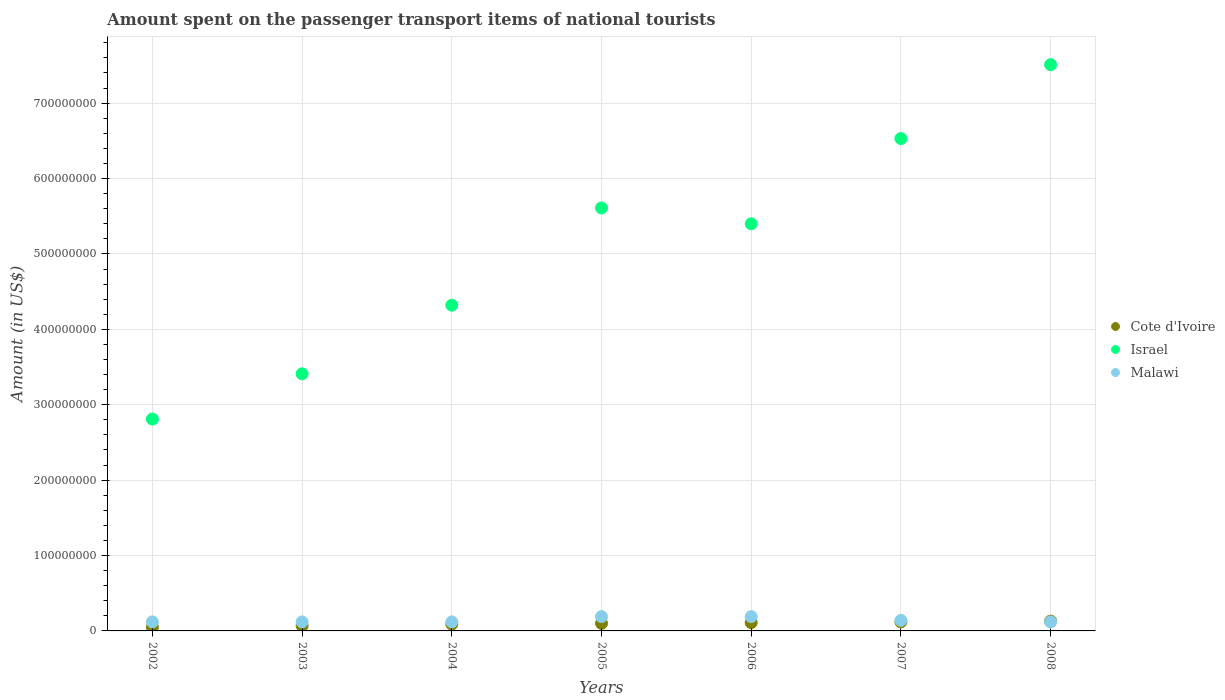What is the amount spent on the passenger transport items of national tourists in Malawi in 2005?
Provide a succinct answer. 1.90e+07. Across all years, what is the maximum amount spent on the passenger transport items of national tourists in Malawi?
Your answer should be very brief. 1.90e+07. Across all years, what is the minimum amount spent on the passenger transport items of national tourists in Israel?
Make the answer very short. 2.81e+08. In which year was the amount spent on the passenger transport items of national tourists in Cote d'Ivoire maximum?
Offer a terse response. 2008. What is the total amount spent on the passenger transport items of national tourists in Israel in the graph?
Your answer should be compact. 3.56e+09. What is the difference between the amount spent on the passenger transport items of national tourists in Cote d'Ivoire in 2003 and that in 2007?
Provide a short and direct response. -5.00e+06. What is the average amount spent on the passenger transport items of national tourists in Cote d'Ivoire per year?
Provide a succinct answer. 9.57e+06. In the year 2008, what is the difference between the amount spent on the passenger transport items of national tourists in Malawi and amount spent on the passenger transport items of national tourists in Israel?
Give a very brief answer. -7.39e+08. What is the ratio of the amount spent on the passenger transport items of national tourists in Israel in 2004 to that in 2008?
Your answer should be compact. 0.58. Is the difference between the amount spent on the passenger transport items of national tourists in Malawi in 2003 and 2006 greater than the difference between the amount spent on the passenger transport items of national tourists in Israel in 2003 and 2006?
Keep it short and to the point. Yes. What is the difference between the highest and the second highest amount spent on the passenger transport items of national tourists in Israel?
Provide a succinct answer. 9.80e+07. What is the difference between the highest and the lowest amount spent on the passenger transport items of national tourists in Malawi?
Your answer should be very brief. 7.00e+06. How many years are there in the graph?
Keep it short and to the point. 7. Does the graph contain any zero values?
Offer a very short reply. No. Does the graph contain grids?
Offer a terse response. Yes. Where does the legend appear in the graph?
Provide a succinct answer. Center right. What is the title of the graph?
Give a very brief answer. Amount spent on the passenger transport items of national tourists. What is the label or title of the Y-axis?
Provide a succinct answer. Amount (in US$). What is the Amount (in US$) in Cote d'Ivoire in 2002?
Offer a terse response. 5.00e+06. What is the Amount (in US$) of Israel in 2002?
Your answer should be compact. 2.81e+08. What is the Amount (in US$) of Malawi in 2002?
Your answer should be very brief. 1.20e+07. What is the Amount (in US$) in Israel in 2003?
Make the answer very short. 3.41e+08. What is the Amount (in US$) of Malawi in 2003?
Offer a terse response. 1.20e+07. What is the Amount (in US$) in Cote d'Ivoire in 2004?
Your answer should be very brief. 9.00e+06. What is the Amount (in US$) in Israel in 2004?
Offer a very short reply. 4.32e+08. What is the Amount (in US$) in Malawi in 2004?
Make the answer very short. 1.20e+07. What is the Amount (in US$) in Israel in 2005?
Provide a succinct answer. 5.61e+08. What is the Amount (in US$) of Malawi in 2005?
Provide a succinct answer. 1.90e+07. What is the Amount (in US$) in Cote d'Ivoire in 2006?
Your answer should be very brief. 1.10e+07. What is the Amount (in US$) in Israel in 2006?
Make the answer very short. 5.40e+08. What is the Amount (in US$) in Malawi in 2006?
Your answer should be compact. 1.90e+07. What is the Amount (in US$) in Cote d'Ivoire in 2007?
Your answer should be very brief. 1.20e+07. What is the Amount (in US$) in Israel in 2007?
Keep it short and to the point. 6.53e+08. What is the Amount (in US$) in Malawi in 2007?
Provide a short and direct response. 1.40e+07. What is the Amount (in US$) in Cote d'Ivoire in 2008?
Keep it short and to the point. 1.30e+07. What is the Amount (in US$) of Israel in 2008?
Your answer should be very brief. 7.51e+08. What is the Amount (in US$) of Malawi in 2008?
Provide a short and direct response. 1.20e+07. Across all years, what is the maximum Amount (in US$) of Cote d'Ivoire?
Provide a short and direct response. 1.30e+07. Across all years, what is the maximum Amount (in US$) in Israel?
Give a very brief answer. 7.51e+08. Across all years, what is the maximum Amount (in US$) in Malawi?
Your answer should be very brief. 1.90e+07. Across all years, what is the minimum Amount (in US$) of Israel?
Offer a very short reply. 2.81e+08. What is the total Amount (in US$) in Cote d'Ivoire in the graph?
Keep it short and to the point. 6.70e+07. What is the total Amount (in US$) of Israel in the graph?
Your answer should be very brief. 3.56e+09. What is the total Amount (in US$) of Malawi in the graph?
Your answer should be compact. 1.00e+08. What is the difference between the Amount (in US$) of Israel in 2002 and that in 2003?
Your answer should be very brief. -6.00e+07. What is the difference between the Amount (in US$) in Israel in 2002 and that in 2004?
Offer a terse response. -1.51e+08. What is the difference between the Amount (in US$) in Cote d'Ivoire in 2002 and that in 2005?
Offer a very short reply. -5.00e+06. What is the difference between the Amount (in US$) in Israel in 2002 and that in 2005?
Provide a short and direct response. -2.80e+08. What is the difference between the Amount (in US$) in Malawi in 2002 and that in 2005?
Give a very brief answer. -7.00e+06. What is the difference between the Amount (in US$) in Cote d'Ivoire in 2002 and that in 2006?
Offer a terse response. -6.00e+06. What is the difference between the Amount (in US$) of Israel in 2002 and that in 2006?
Your answer should be compact. -2.59e+08. What is the difference between the Amount (in US$) in Malawi in 2002 and that in 2006?
Give a very brief answer. -7.00e+06. What is the difference between the Amount (in US$) in Cote d'Ivoire in 2002 and that in 2007?
Your answer should be compact. -7.00e+06. What is the difference between the Amount (in US$) of Israel in 2002 and that in 2007?
Make the answer very short. -3.72e+08. What is the difference between the Amount (in US$) in Malawi in 2002 and that in 2007?
Your response must be concise. -2.00e+06. What is the difference between the Amount (in US$) of Cote d'Ivoire in 2002 and that in 2008?
Your answer should be compact. -8.00e+06. What is the difference between the Amount (in US$) in Israel in 2002 and that in 2008?
Ensure brevity in your answer.  -4.70e+08. What is the difference between the Amount (in US$) in Israel in 2003 and that in 2004?
Offer a terse response. -9.10e+07. What is the difference between the Amount (in US$) in Cote d'Ivoire in 2003 and that in 2005?
Ensure brevity in your answer.  -3.00e+06. What is the difference between the Amount (in US$) in Israel in 2003 and that in 2005?
Your response must be concise. -2.20e+08. What is the difference between the Amount (in US$) of Malawi in 2003 and that in 2005?
Offer a terse response. -7.00e+06. What is the difference between the Amount (in US$) of Israel in 2003 and that in 2006?
Offer a terse response. -1.99e+08. What is the difference between the Amount (in US$) of Malawi in 2003 and that in 2006?
Provide a short and direct response. -7.00e+06. What is the difference between the Amount (in US$) of Cote d'Ivoire in 2003 and that in 2007?
Provide a short and direct response. -5.00e+06. What is the difference between the Amount (in US$) of Israel in 2003 and that in 2007?
Ensure brevity in your answer.  -3.12e+08. What is the difference between the Amount (in US$) in Malawi in 2003 and that in 2007?
Your answer should be compact. -2.00e+06. What is the difference between the Amount (in US$) in Cote d'Ivoire in 2003 and that in 2008?
Your answer should be very brief. -6.00e+06. What is the difference between the Amount (in US$) in Israel in 2003 and that in 2008?
Your response must be concise. -4.10e+08. What is the difference between the Amount (in US$) of Malawi in 2003 and that in 2008?
Offer a very short reply. 0. What is the difference between the Amount (in US$) of Cote d'Ivoire in 2004 and that in 2005?
Give a very brief answer. -1.00e+06. What is the difference between the Amount (in US$) of Israel in 2004 and that in 2005?
Keep it short and to the point. -1.29e+08. What is the difference between the Amount (in US$) in Malawi in 2004 and that in 2005?
Your answer should be very brief. -7.00e+06. What is the difference between the Amount (in US$) of Israel in 2004 and that in 2006?
Offer a terse response. -1.08e+08. What is the difference between the Amount (in US$) in Malawi in 2004 and that in 2006?
Your answer should be compact. -7.00e+06. What is the difference between the Amount (in US$) of Cote d'Ivoire in 2004 and that in 2007?
Give a very brief answer. -3.00e+06. What is the difference between the Amount (in US$) of Israel in 2004 and that in 2007?
Your answer should be compact. -2.21e+08. What is the difference between the Amount (in US$) in Malawi in 2004 and that in 2007?
Offer a very short reply. -2.00e+06. What is the difference between the Amount (in US$) in Israel in 2004 and that in 2008?
Your answer should be very brief. -3.19e+08. What is the difference between the Amount (in US$) of Malawi in 2004 and that in 2008?
Your answer should be very brief. 0. What is the difference between the Amount (in US$) of Israel in 2005 and that in 2006?
Provide a succinct answer. 2.10e+07. What is the difference between the Amount (in US$) of Malawi in 2005 and that in 2006?
Your answer should be compact. 0. What is the difference between the Amount (in US$) in Israel in 2005 and that in 2007?
Your answer should be compact. -9.20e+07. What is the difference between the Amount (in US$) in Malawi in 2005 and that in 2007?
Your answer should be very brief. 5.00e+06. What is the difference between the Amount (in US$) of Israel in 2005 and that in 2008?
Your answer should be compact. -1.90e+08. What is the difference between the Amount (in US$) in Israel in 2006 and that in 2007?
Ensure brevity in your answer.  -1.13e+08. What is the difference between the Amount (in US$) of Malawi in 2006 and that in 2007?
Make the answer very short. 5.00e+06. What is the difference between the Amount (in US$) of Cote d'Ivoire in 2006 and that in 2008?
Offer a terse response. -2.00e+06. What is the difference between the Amount (in US$) in Israel in 2006 and that in 2008?
Provide a succinct answer. -2.11e+08. What is the difference between the Amount (in US$) in Cote d'Ivoire in 2007 and that in 2008?
Keep it short and to the point. -1.00e+06. What is the difference between the Amount (in US$) in Israel in 2007 and that in 2008?
Give a very brief answer. -9.80e+07. What is the difference between the Amount (in US$) in Cote d'Ivoire in 2002 and the Amount (in US$) in Israel in 2003?
Your response must be concise. -3.36e+08. What is the difference between the Amount (in US$) of Cote d'Ivoire in 2002 and the Amount (in US$) of Malawi in 2003?
Provide a succinct answer. -7.00e+06. What is the difference between the Amount (in US$) in Israel in 2002 and the Amount (in US$) in Malawi in 2003?
Ensure brevity in your answer.  2.69e+08. What is the difference between the Amount (in US$) in Cote d'Ivoire in 2002 and the Amount (in US$) in Israel in 2004?
Offer a terse response. -4.27e+08. What is the difference between the Amount (in US$) in Cote d'Ivoire in 2002 and the Amount (in US$) in Malawi in 2004?
Offer a very short reply. -7.00e+06. What is the difference between the Amount (in US$) of Israel in 2002 and the Amount (in US$) of Malawi in 2004?
Provide a succinct answer. 2.69e+08. What is the difference between the Amount (in US$) in Cote d'Ivoire in 2002 and the Amount (in US$) in Israel in 2005?
Offer a very short reply. -5.56e+08. What is the difference between the Amount (in US$) of Cote d'Ivoire in 2002 and the Amount (in US$) of Malawi in 2005?
Your answer should be compact. -1.40e+07. What is the difference between the Amount (in US$) of Israel in 2002 and the Amount (in US$) of Malawi in 2005?
Offer a very short reply. 2.62e+08. What is the difference between the Amount (in US$) in Cote d'Ivoire in 2002 and the Amount (in US$) in Israel in 2006?
Provide a short and direct response. -5.35e+08. What is the difference between the Amount (in US$) in Cote d'Ivoire in 2002 and the Amount (in US$) in Malawi in 2006?
Provide a succinct answer. -1.40e+07. What is the difference between the Amount (in US$) of Israel in 2002 and the Amount (in US$) of Malawi in 2006?
Your answer should be very brief. 2.62e+08. What is the difference between the Amount (in US$) of Cote d'Ivoire in 2002 and the Amount (in US$) of Israel in 2007?
Give a very brief answer. -6.48e+08. What is the difference between the Amount (in US$) in Cote d'Ivoire in 2002 and the Amount (in US$) in Malawi in 2007?
Your answer should be very brief. -9.00e+06. What is the difference between the Amount (in US$) in Israel in 2002 and the Amount (in US$) in Malawi in 2007?
Your response must be concise. 2.67e+08. What is the difference between the Amount (in US$) in Cote d'Ivoire in 2002 and the Amount (in US$) in Israel in 2008?
Your answer should be very brief. -7.46e+08. What is the difference between the Amount (in US$) of Cote d'Ivoire in 2002 and the Amount (in US$) of Malawi in 2008?
Ensure brevity in your answer.  -7.00e+06. What is the difference between the Amount (in US$) in Israel in 2002 and the Amount (in US$) in Malawi in 2008?
Offer a terse response. 2.69e+08. What is the difference between the Amount (in US$) of Cote d'Ivoire in 2003 and the Amount (in US$) of Israel in 2004?
Make the answer very short. -4.25e+08. What is the difference between the Amount (in US$) in Cote d'Ivoire in 2003 and the Amount (in US$) in Malawi in 2004?
Provide a succinct answer. -5.00e+06. What is the difference between the Amount (in US$) of Israel in 2003 and the Amount (in US$) of Malawi in 2004?
Keep it short and to the point. 3.29e+08. What is the difference between the Amount (in US$) in Cote d'Ivoire in 2003 and the Amount (in US$) in Israel in 2005?
Give a very brief answer. -5.54e+08. What is the difference between the Amount (in US$) of Cote d'Ivoire in 2003 and the Amount (in US$) of Malawi in 2005?
Keep it short and to the point. -1.20e+07. What is the difference between the Amount (in US$) of Israel in 2003 and the Amount (in US$) of Malawi in 2005?
Give a very brief answer. 3.22e+08. What is the difference between the Amount (in US$) of Cote d'Ivoire in 2003 and the Amount (in US$) of Israel in 2006?
Keep it short and to the point. -5.33e+08. What is the difference between the Amount (in US$) of Cote d'Ivoire in 2003 and the Amount (in US$) of Malawi in 2006?
Your response must be concise. -1.20e+07. What is the difference between the Amount (in US$) of Israel in 2003 and the Amount (in US$) of Malawi in 2006?
Keep it short and to the point. 3.22e+08. What is the difference between the Amount (in US$) in Cote d'Ivoire in 2003 and the Amount (in US$) in Israel in 2007?
Give a very brief answer. -6.46e+08. What is the difference between the Amount (in US$) of Cote d'Ivoire in 2003 and the Amount (in US$) of Malawi in 2007?
Offer a very short reply. -7.00e+06. What is the difference between the Amount (in US$) of Israel in 2003 and the Amount (in US$) of Malawi in 2007?
Your answer should be very brief. 3.27e+08. What is the difference between the Amount (in US$) in Cote d'Ivoire in 2003 and the Amount (in US$) in Israel in 2008?
Your answer should be compact. -7.44e+08. What is the difference between the Amount (in US$) in Cote d'Ivoire in 2003 and the Amount (in US$) in Malawi in 2008?
Provide a succinct answer. -5.00e+06. What is the difference between the Amount (in US$) in Israel in 2003 and the Amount (in US$) in Malawi in 2008?
Your answer should be very brief. 3.29e+08. What is the difference between the Amount (in US$) in Cote d'Ivoire in 2004 and the Amount (in US$) in Israel in 2005?
Your answer should be compact. -5.52e+08. What is the difference between the Amount (in US$) in Cote d'Ivoire in 2004 and the Amount (in US$) in Malawi in 2005?
Your answer should be compact. -1.00e+07. What is the difference between the Amount (in US$) of Israel in 2004 and the Amount (in US$) of Malawi in 2005?
Offer a terse response. 4.13e+08. What is the difference between the Amount (in US$) of Cote d'Ivoire in 2004 and the Amount (in US$) of Israel in 2006?
Offer a very short reply. -5.31e+08. What is the difference between the Amount (in US$) of Cote d'Ivoire in 2004 and the Amount (in US$) of Malawi in 2006?
Your answer should be very brief. -1.00e+07. What is the difference between the Amount (in US$) in Israel in 2004 and the Amount (in US$) in Malawi in 2006?
Your response must be concise. 4.13e+08. What is the difference between the Amount (in US$) in Cote d'Ivoire in 2004 and the Amount (in US$) in Israel in 2007?
Provide a short and direct response. -6.44e+08. What is the difference between the Amount (in US$) of Cote d'Ivoire in 2004 and the Amount (in US$) of Malawi in 2007?
Ensure brevity in your answer.  -5.00e+06. What is the difference between the Amount (in US$) in Israel in 2004 and the Amount (in US$) in Malawi in 2007?
Ensure brevity in your answer.  4.18e+08. What is the difference between the Amount (in US$) in Cote d'Ivoire in 2004 and the Amount (in US$) in Israel in 2008?
Make the answer very short. -7.42e+08. What is the difference between the Amount (in US$) of Israel in 2004 and the Amount (in US$) of Malawi in 2008?
Give a very brief answer. 4.20e+08. What is the difference between the Amount (in US$) of Cote d'Ivoire in 2005 and the Amount (in US$) of Israel in 2006?
Your answer should be compact. -5.30e+08. What is the difference between the Amount (in US$) in Cote d'Ivoire in 2005 and the Amount (in US$) in Malawi in 2006?
Ensure brevity in your answer.  -9.00e+06. What is the difference between the Amount (in US$) of Israel in 2005 and the Amount (in US$) of Malawi in 2006?
Keep it short and to the point. 5.42e+08. What is the difference between the Amount (in US$) in Cote d'Ivoire in 2005 and the Amount (in US$) in Israel in 2007?
Keep it short and to the point. -6.43e+08. What is the difference between the Amount (in US$) in Cote d'Ivoire in 2005 and the Amount (in US$) in Malawi in 2007?
Offer a terse response. -4.00e+06. What is the difference between the Amount (in US$) of Israel in 2005 and the Amount (in US$) of Malawi in 2007?
Your response must be concise. 5.47e+08. What is the difference between the Amount (in US$) in Cote d'Ivoire in 2005 and the Amount (in US$) in Israel in 2008?
Give a very brief answer. -7.41e+08. What is the difference between the Amount (in US$) in Cote d'Ivoire in 2005 and the Amount (in US$) in Malawi in 2008?
Provide a succinct answer. -2.00e+06. What is the difference between the Amount (in US$) in Israel in 2005 and the Amount (in US$) in Malawi in 2008?
Keep it short and to the point. 5.49e+08. What is the difference between the Amount (in US$) in Cote d'Ivoire in 2006 and the Amount (in US$) in Israel in 2007?
Keep it short and to the point. -6.42e+08. What is the difference between the Amount (in US$) of Israel in 2006 and the Amount (in US$) of Malawi in 2007?
Your answer should be very brief. 5.26e+08. What is the difference between the Amount (in US$) in Cote d'Ivoire in 2006 and the Amount (in US$) in Israel in 2008?
Make the answer very short. -7.40e+08. What is the difference between the Amount (in US$) in Cote d'Ivoire in 2006 and the Amount (in US$) in Malawi in 2008?
Your answer should be compact. -1.00e+06. What is the difference between the Amount (in US$) in Israel in 2006 and the Amount (in US$) in Malawi in 2008?
Your response must be concise. 5.28e+08. What is the difference between the Amount (in US$) of Cote d'Ivoire in 2007 and the Amount (in US$) of Israel in 2008?
Your answer should be very brief. -7.39e+08. What is the difference between the Amount (in US$) in Cote d'Ivoire in 2007 and the Amount (in US$) in Malawi in 2008?
Give a very brief answer. 0. What is the difference between the Amount (in US$) of Israel in 2007 and the Amount (in US$) of Malawi in 2008?
Give a very brief answer. 6.41e+08. What is the average Amount (in US$) in Cote d'Ivoire per year?
Give a very brief answer. 9.57e+06. What is the average Amount (in US$) in Israel per year?
Ensure brevity in your answer.  5.08e+08. What is the average Amount (in US$) in Malawi per year?
Offer a very short reply. 1.43e+07. In the year 2002, what is the difference between the Amount (in US$) in Cote d'Ivoire and Amount (in US$) in Israel?
Your response must be concise. -2.76e+08. In the year 2002, what is the difference between the Amount (in US$) in Cote d'Ivoire and Amount (in US$) in Malawi?
Your answer should be compact. -7.00e+06. In the year 2002, what is the difference between the Amount (in US$) of Israel and Amount (in US$) of Malawi?
Provide a succinct answer. 2.69e+08. In the year 2003, what is the difference between the Amount (in US$) in Cote d'Ivoire and Amount (in US$) in Israel?
Give a very brief answer. -3.34e+08. In the year 2003, what is the difference between the Amount (in US$) of Cote d'Ivoire and Amount (in US$) of Malawi?
Offer a terse response. -5.00e+06. In the year 2003, what is the difference between the Amount (in US$) in Israel and Amount (in US$) in Malawi?
Your response must be concise. 3.29e+08. In the year 2004, what is the difference between the Amount (in US$) in Cote d'Ivoire and Amount (in US$) in Israel?
Provide a succinct answer. -4.23e+08. In the year 2004, what is the difference between the Amount (in US$) in Cote d'Ivoire and Amount (in US$) in Malawi?
Provide a short and direct response. -3.00e+06. In the year 2004, what is the difference between the Amount (in US$) in Israel and Amount (in US$) in Malawi?
Your response must be concise. 4.20e+08. In the year 2005, what is the difference between the Amount (in US$) of Cote d'Ivoire and Amount (in US$) of Israel?
Make the answer very short. -5.51e+08. In the year 2005, what is the difference between the Amount (in US$) in Cote d'Ivoire and Amount (in US$) in Malawi?
Provide a short and direct response. -9.00e+06. In the year 2005, what is the difference between the Amount (in US$) in Israel and Amount (in US$) in Malawi?
Make the answer very short. 5.42e+08. In the year 2006, what is the difference between the Amount (in US$) in Cote d'Ivoire and Amount (in US$) in Israel?
Ensure brevity in your answer.  -5.29e+08. In the year 2006, what is the difference between the Amount (in US$) in Cote d'Ivoire and Amount (in US$) in Malawi?
Keep it short and to the point. -8.00e+06. In the year 2006, what is the difference between the Amount (in US$) of Israel and Amount (in US$) of Malawi?
Your response must be concise. 5.21e+08. In the year 2007, what is the difference between the Amount (in US$) of Cote d'Ivoire and Amount (in US$) of Israel?
Your answer should be compact. -6.41e+08. In the year 2007, what is the difference between the Amount (in US$) of Cote d'Ivoire and Amount (in US$) of Malawi?
Keep it short and to the point. -2.00e+06. In the year 2007, what is the difference between the Amount (in US$) in Israel and Amount (in US$) in Malawi?
Offer a terse response. 6.39e+08. In the year 2008, what is the difference between the Amount (in US$) in Cote d'Ivoire and Amount (in US$) in Israel?
Provide a short and direct response. -7.38e+08. In the year 2008, what is the difference between the Amount (in US$) of Israel and Amount (in US$) of Malawi?
Your answer should be very brief. 7.39e+08. What is the ratio of the Amount (in US$) of Cote d'Ivoire in 2002 to that in 2003?
Your response must be concise. 0.71. What is the ratio of the Amount (in US$) in Israel in 2002 to that in 2003?
Your answer should be very brief. 0.82. What is the ratio of the Amount (in US$) of Malawi in 2002 to that in 2003?
Give a very brief answer. 1. What is the ratio of the Amount (in US$) in Cote d'Ivoire in 2002 to that in 2004?
Your answer should be very brief. 0.56. What is the ratio of the Amount (in US$) of Israel in 2002 to that in 2004?
Offer a very short reply. 0.65. What is the ratio of the Amount (in US$) in Malawi in 2002 to that in 2004?
Provide a succinct answer. 1. What is the ratio of the Amount (in US$) of Cote d'Ivoire in 2002 to that in 2005?
Your answer should be very brief. 0.5. What is the ratio of the Amount (in US$) in Israel in 2002 to that in 2005?
Your answer should be compact. 0.5. What is the ratio of the Amount (in US$) of Malawi in 2002 to that in 2005?
Your response must be concise. 0.63. What is the ratio of the Amount (in US$) in Cote d'Ivoire in 2002 to that in 2006?
Provide a short and direct response. 0.45. What is the ratio of the Amount (in US$) of Israel in 2002 to that in 2006?
Ensure brevity in your answer.  0.52. What is the ratio of the Amount (in US$) in Malawi in 2002 to that in 2006?
Your answer should be compact. 0.63. What is the ratio of the Amount (in US$) of Cote d'Ivoire in 2002 to that in 2007?
Provide a succinct answer. 0.42. What is the ratio of the Amount (in US$) of Israel in 2002 to that in 2007?
Offer a very short reply. 0.43. What is the ratio of the Amount (in US$) of Malawi in 2002 to that in 2007?
Offer a terse response. 0.86. What is the ratio of the Amount (in US$) in Cote d'Ivoire in 2002 to that in 2008?
Provide a short and direct response. 0.38. What is the ratio of the Amount (in US$) in Israel in 2002 to that in 2008?
Offer a terse response. 0.37. What is the ratio of the Amount (in US$) in Malawi in 2002 to that in 2008?
Make the answer very short. 1. What is the ratio of the Amount (in US$) of Cote d'Ivoire in 2003 to that in 2004?
Keep it short and to the point. 0.78. What is the ratio of the Amount (in US$) of Israel in 2003 to that in 2004?
Offer a very short reply. 0.79. What is the ratio of the Amount (in US$) of Malawi in 2003 to that in 2004?
Your answer should be very brief. 1. What is the ratio of the Amount (in US$) in Cote d'Ivoire in 2003 to that in 2005?
Your answer should be very brief. 0.7. What is the ratio of the Amount (in US$) in Israel in 2003 to that in 2005?
Your answer should be very brief. 0.61. What is the ratio of the Amount (in US$) in Malawi in 2003 to that in 2005?
Keep it short and to the point. 0.63. What is the ratio of the Amount (in US$) of Cote d'Ivoire in 2003 to that in 2006?
Offer a very short reply. 0.64. What is the ratio of the Amount (in US$) of Israel in 2003 to that in 2006?
Make the answer very short. 0.63. What is the ratio of the Amount (in US$) in Malawi in 2003 to that in 2006?
Ensure brevity in your answer.  0.63. What is the ratio of the Amount (in US$) in Cote d'Ivoire in 2003 to that in 2007?
Your answer should be compact. 0.58. What is the ratio of the Amount (in US$) in Israel in 2003 to that in 2007?
Offer a very short reply. 0.52. What is the ratio of the Amount (in US$) of Malawi in 2003 to that in 2007?
Your answer should be very brief. 0.86. What is the ratio of the Amount (in US$) of Cote d'Ivoire in 2003 to that in 2008?
Keep it short and to the point. 0.54. What is the ratio of the Amount (in US$) in Israel in 2003 to that in 2008?
Offer a terse response. 0.45. What is the ratio of the Amount (in US$) in Malawi in 2003 to that in 2008?
Make the answer very short. 1. What is the ratio of the Amount (in US$) in Israel in 2004 to that in 2005?
Ensure brevity in your answer.  0.77. What is the ratio of the Amount (in US$) in Malawi in 2004 to that in 2005?
Your response must be concise. 0.63. What is the ratio of the Amount (in US$) in Cote d'Ivoire in 2004 to that in 2006?
Your answer should be compact. 0.82. What is the ratio of the Amount (in US$) in Israel in 2004 to that in 2006?
Your answer should be compact. 0.8. What is the ratio of the Amount (in US$) in Malawi in 2004 to that in 2006?
Keep it short and to the point. 0.63. What is the ratio of the Amount (in US$) in Israel in 2004 to that in 2007?
Your response must be concise. 0.66. What is the ratio of the Amount (in US$) of Malawi in 2004 to that in 2007?
Keep it short and to the point. 0.86. What is the ratio of the Amount (in US$) in Cote d'Ivoire in 2004 to that in 2008?
Give a very brief answer. 0.69. What is the ratio of the Amount (in US$) in Israel in 2004 to that in 2008?
Offer a very short reply. 0.58. What is the ratio of the Amount (in US$) of Malawi in 2004 to that in 2008?
Your answer should be compact. 1. What is the ratio of the Amount (in US$) of Israel in 2005 to that in 2006?
Keep it short and to the point. 1.04. What is the ratio of the Amount (in US$) in Malawi in 2005 to that in 2006?
Provide a succinct answer. 1. What is the ratio of the Amount (in US$) of Cote d'Ivoire in 2005 to that in 2007?
Your answer should be very brief. 0.83. What is the ratio of the Amount (in US$) of Israel in 2005 to that in 2007?
Your response must be concise. 0.86. What is the ratio of the Amount (in US$) of Malawi in 2005 to that in 2007?
Make the answer very short. 1.36. What is the ratio of the Amount (in US$) in Cote d'Ivoire in 2005 to that in 2008?
Give a very brief answer. 0.77. What is the ratio of the Amount (in US$) of Israel in 2005 to that in 2008?
Offer a very short reply. 0.75. What is the ratio of the Amount (in US$) of Malawi in 2005 to that in 2008?
Give a very brief answer. 1.58. What is the ratio of the Amount (in US$) of Israel in 2006 to that in 2007?
Ensure brevity in your answer.  0.83. What is the ratio of the Amount (in US$) in Malawi in 2006 to that in 2007?
Your answer should be very brief. 1.36. What is the ratio of the Amount (in US$) in Cote d'Ivoire in 2006 to that in 2008?
Your answer should be very brief. 0.85. What is the ratio of the Amount (in US$) in Israel in 2006 to that in 2008?
Your answer should be compact. 0.72. What is the ratio of the Amount (in US$) of Malawi in 2006 to that in 2008?
Provide a short and direct response. 1.58. What is the ratio of the Amount (in US$) of Cote d'Ivoire in 2007 to that in 2008?
Make the answer very short. 0.92. What is the ratio of the Amount (in US$) in Israel in 2007 to that in 2008?
Your answer should be compact. 0.87. What is the difference between the highest and the second highest Amount (in US$) of Cote d'Ivoire?
Offer a terse response. 1.00e+06. What is the difference between the highest and the second highest Amount (in US$) in Israel?
Offer a very short reply. 9.80e+07. What is the difference between the highest and the lowest Amount (in US$) in Israel?
Give a very brief answer. 4.70e+08. What is the difference between the highest and the lowest Amount (in US$) in Malawi?
Offer a terse response. 7.00e+06. 